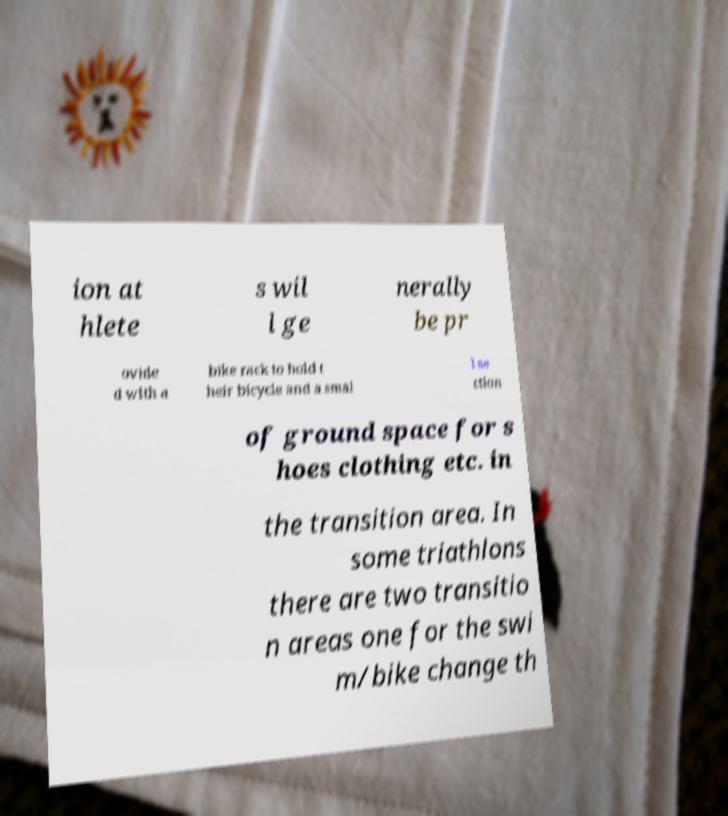Please identify and transcribe the text found in this image. ion at hlete s wil l ge nerally be pr ovide d with a bike rack to hold t heir bicycle and a smal l se ction of ground space for s hoes clothing etc. in the transition area. In some triathlons there are two transitio n areas one for the swi m/bike change th 